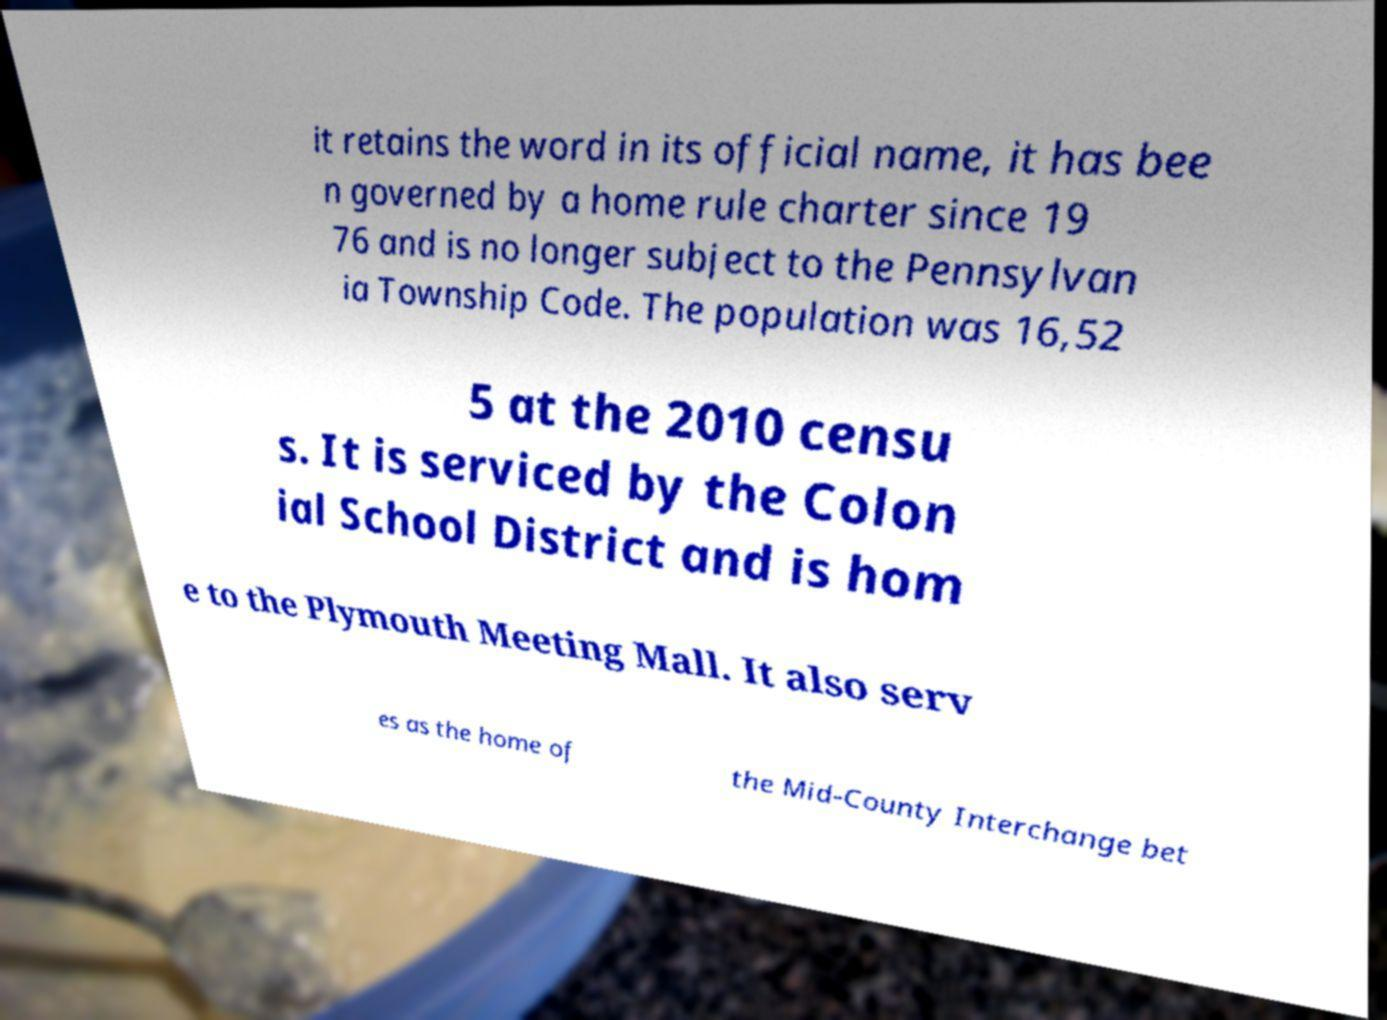Could you extract and type out the text from this image? it retains the word in its official name, it has bee n governed by a home rule charter since 19 76 and is no longer subject to the Pennsylvan ia Township Code. The population was 16,52 5 at the 2010 censu s. It is serviced by the Colon ial School District and is hom e to the Plymouth Meeting Mall. It also serv es as the home of the Mid-County Interchange bet 